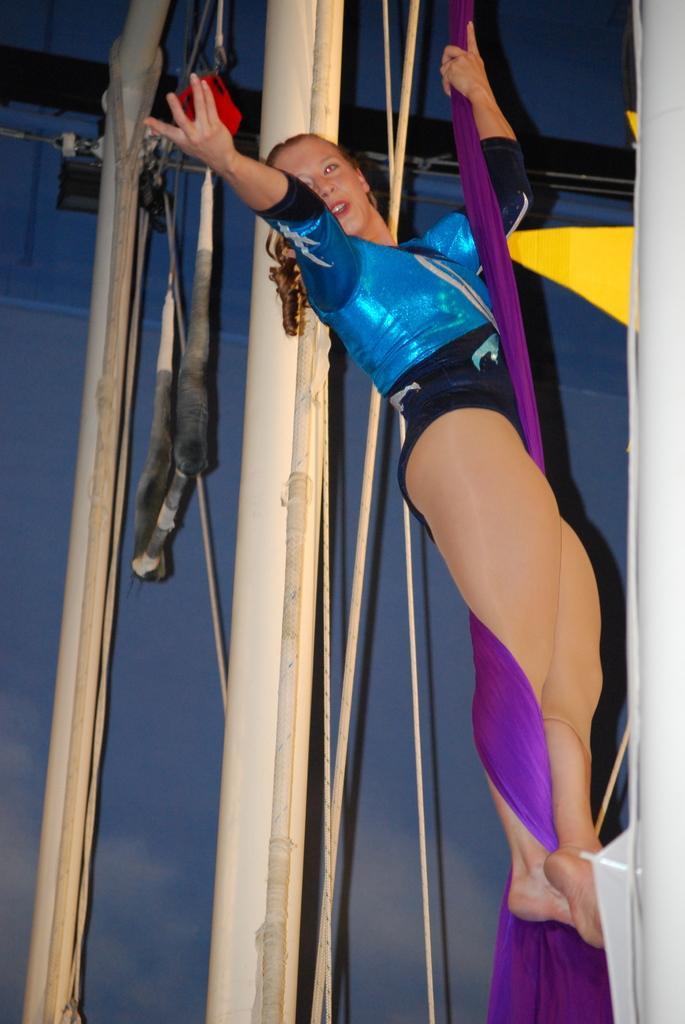Can you describe this image briefly? In this image there is a woman hanging to a rope. Behind her there are metal rods. In the background there is the sky. 